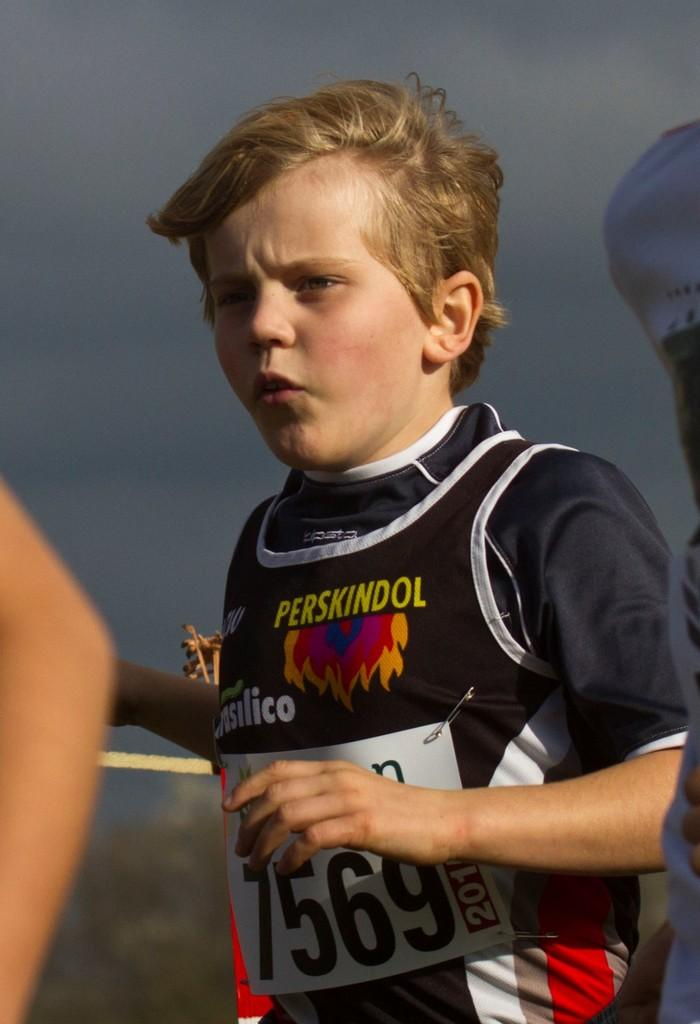Provide a one-sentence caption for the provided image. A young boy with the number 7569 running in a marathon. 